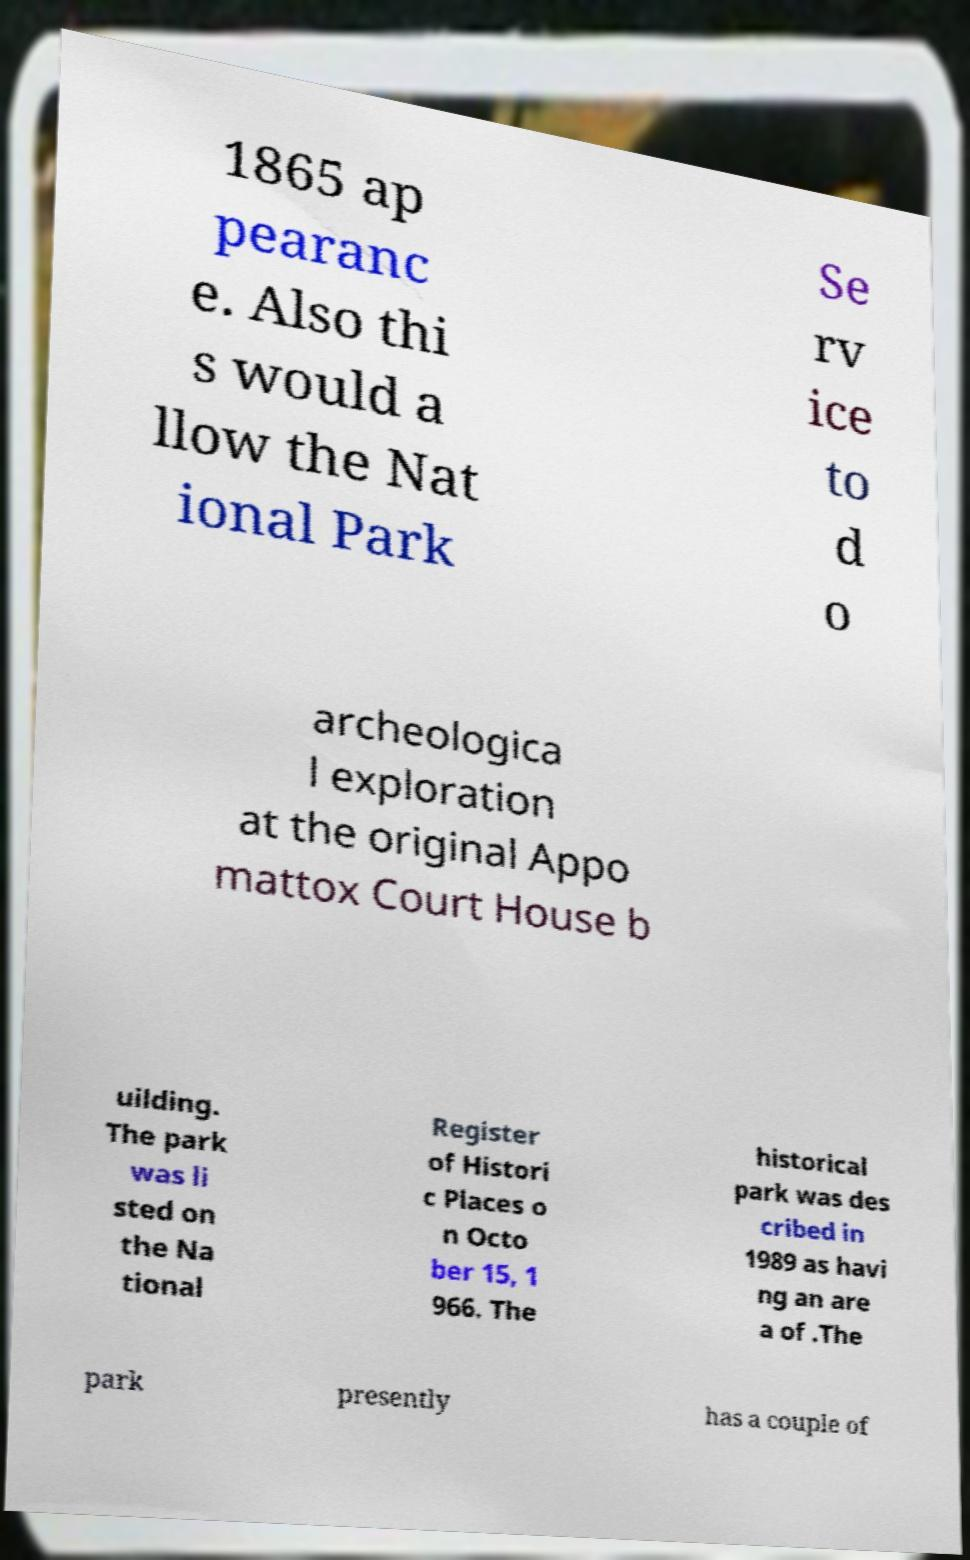Please identify and transcribe the text found in this image. 1865 ap pearanc e. Also thi s would a llow the Nat ional Park Se rv ice to d o archeologica l exploration at the original Appo mattox Court House b uilding. The park was li sted on the Na tional Register of Histori c Places o n Octo ber 15, 1 966. The historical park was des cribed in 1989 as havi ng an are a of .The park presently has a couple of 